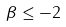<formula> <loc_0><loc_0><loc_500><loc_500>\beta \leq - 2</formula> 